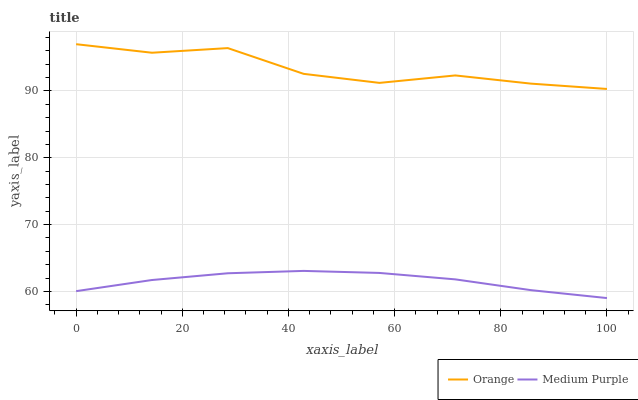Does Medium Purple have the minimum area under the curve?
Answer yes or no. Yes. Does Orange have the maximum area under the curve?
Answer yes or no. Yes. Does Medium Purple have the maximum area under the curve?
Answer yes or no. No. Is Medium Purple the smoothest?
Answer yes or no. Yes. Is Orange the roughest?
Answer yes or no. Yes. Is Medium Purple the roughest?
Answer yes or no. No. Does Orange have the highest value?
Answer yes or no. Yes. Does Medium Purple have the highest value?
Answer yes or no. No. Is Medium Purple less than Orange?
Answer yes or no. Yes. Is Orange greater than Medium Purple?
Answer yes or no. Yes. Does Medium Purple intersect Orange?
Answer yes or no. No. 